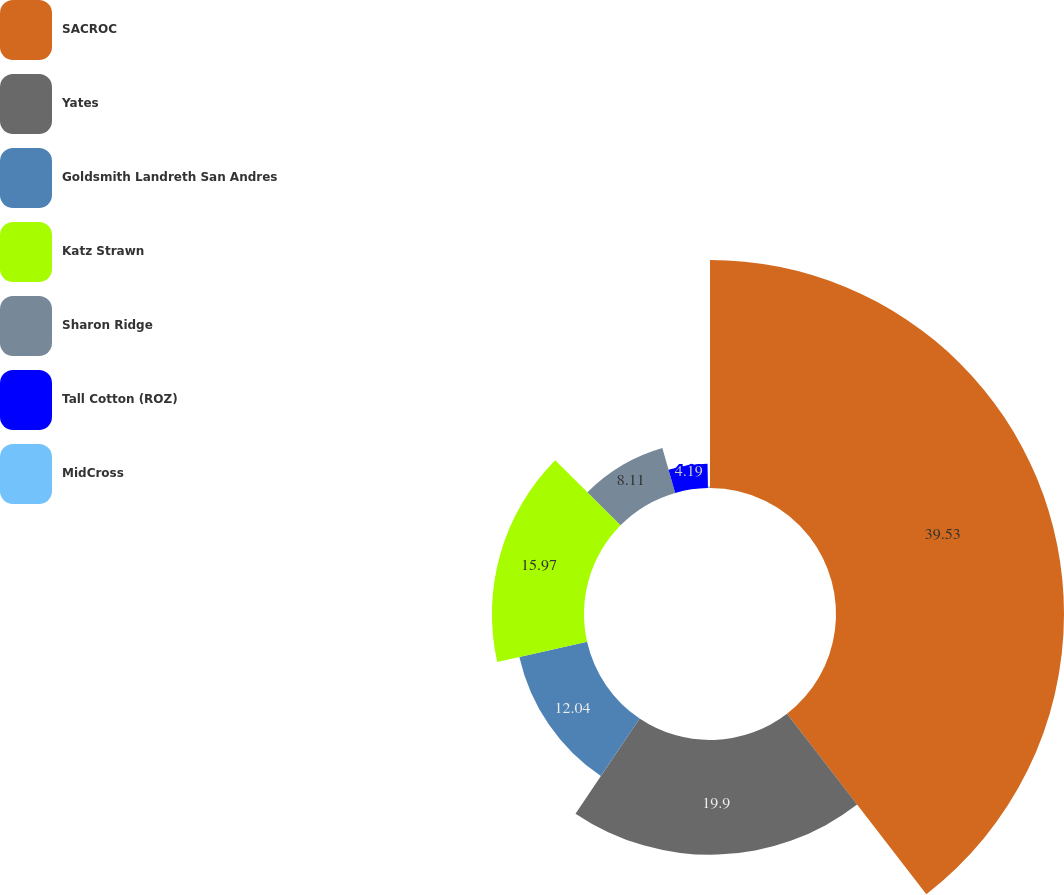Convert chart. <chart><loc_0><loc_0><loc_500><loc_500><pie_chart><fcel>SACROC<fcel>Yates<fcel>Goldsmith Landreth San Andres<fcel>Katz Strawn<fcel>Sharon Ridge<fcel>Tall Cotton (ROZ)<fcel>MidCross<nl><fcel>39.54%<fcel>19.9%<fcel>12.04%<fcel>15.97%<fcel>8.11%<fcel>4.19%<fcel>0.26%<nl></chart> 